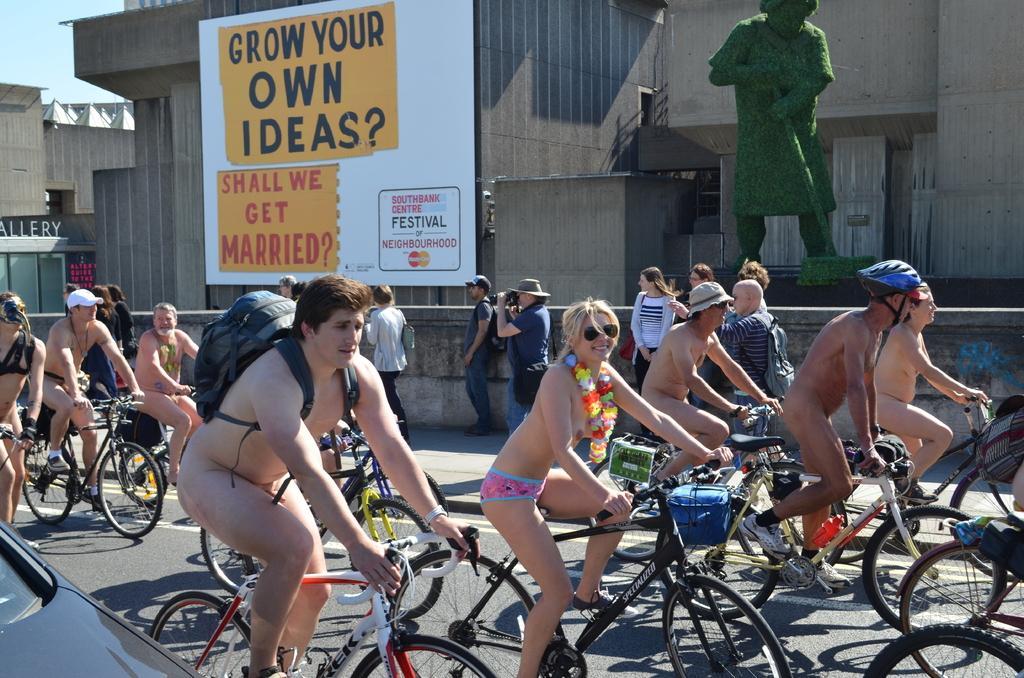Can you describe this image briefly? In this image we can see group of people riding a bicycle. At the background we can see a statue and a board and the person is holding a camera. The man is wearing a backpack. 